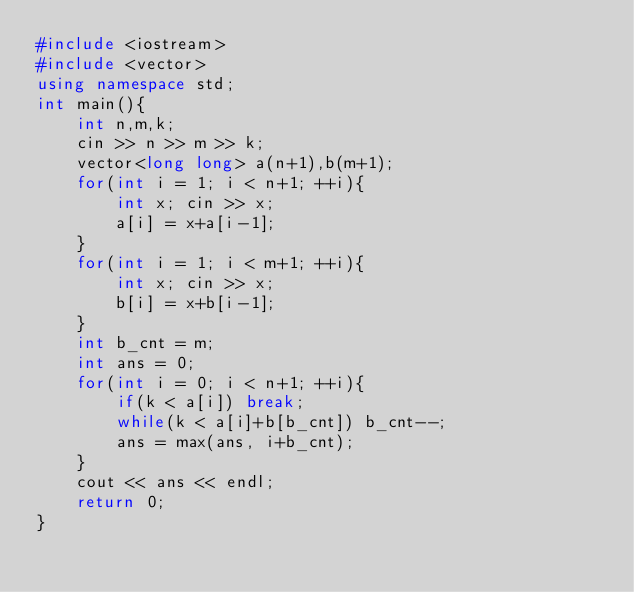Convert code to text. <code><loc_0><loc_0><loc_500><loc_500><_C++_>#include <iostream>
#include <vector>
using namespace std;
int main(){
    int n,m,k;
    cin >> n >> m >> k;
    vector<long long> a(n+1),b(m+1);
    for(int i = 1; i < n+1; ++i){
        int x; cin >> x;
        a[i] = x+a[i-1];
    }
    for(int i = 1; i < m+1; ++i){
        int x; cin >> x;
        b[i] = x+b[i-1];
    }
    int b_cnt = m;
    int ans = 0;
    for(int i = 0; i < n+1; ++i){
        if(k < a[i]) break;
        while(k < a[i]+b[b_cnt]) b_cnt--;
        ans = max(ans, i+b_cnt);
    }
    cout << ans << endl;
    return 0;
}</code> 